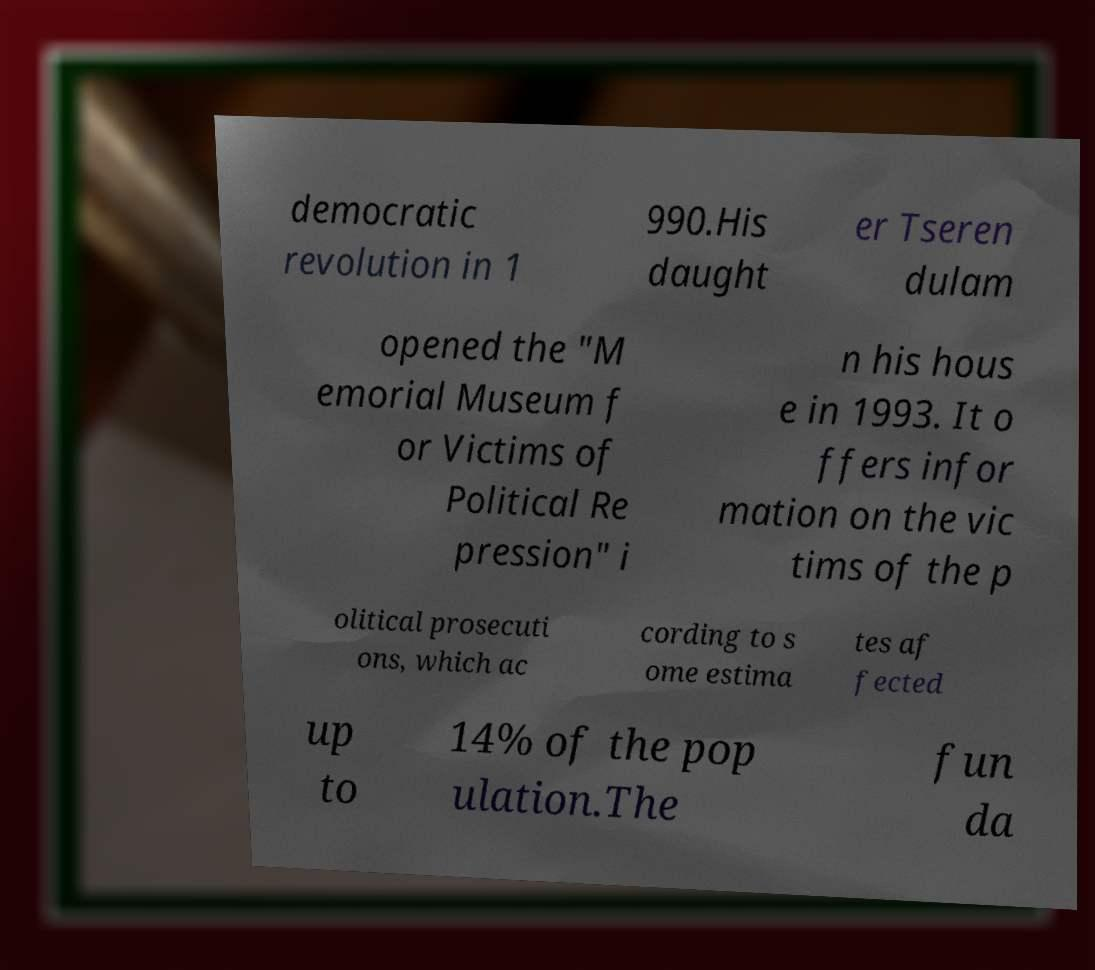For documentation purposes, I need the text within this image transcribed. Could you provide that? democratic revolution in 1 990.His daught er Tseren dulam opened the "M emorial Museum f or Victims of Political Re pression" i n his hous e in 1993. It o ffers infor mation on the vic tims of the p olitical prosecuti ons, which ac cording to s ome estima tes af fected up to 14% of the pop ulation.The fun da 